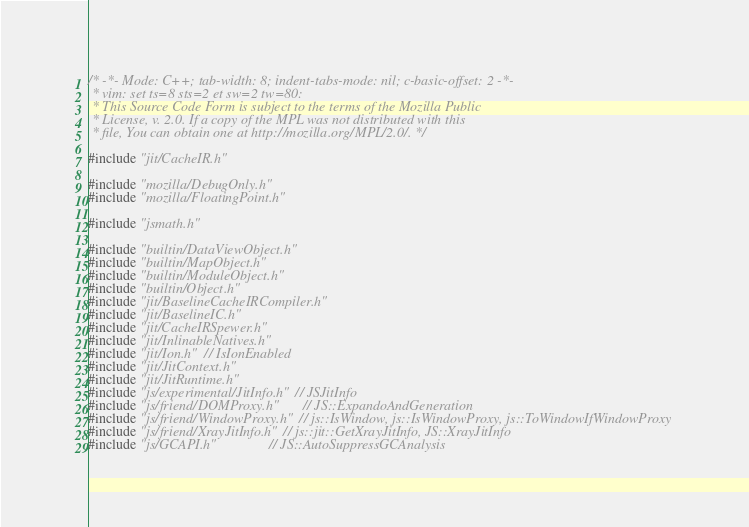Convert code to text. <code><loc_0><loc_0><loc_500><loc_500><_C++_>/* -*- Mode: C++; tab-width: 8; indent-tabs-mode: nil; c-basic-offset: 2 -*-
 * vim: set ts=8 sts=2 et sw=2 tw=80:
 * This Source Code Form is subject to the terms of the Mozilla Public
 * License, v. 2.0. If a copy of the MPL was not distributed with this
 * file, You can obtain one at http://mozilla.org/MPL/2.0/. */

#include "jit/CacheIR.h"

#include "mozilla/DebugOnly.h"
#include "mozilla/FloatingPoint.h"

#include "jsmath.h"

#include "builtin/DataViewObject.h"
#include "builtin/MapObject.h"
#include "builtin/ModuleObject.h"
#include "builtin/Object.h"
#include "jit/BaselineCacheIRCompiler.h"
#include "jit/BaselineIC.h"
#include "jit/CacheIRSpewer.h"
#include "jit/InlinableNatives.h"
#include "jit/Ion.h"  // IsIonEnabled
#include "jit/JitContext.h"
#include "jit/JitRuntime.h"
#include "js/experimental/JitInfo.h"  // JSJitInfo
#include "js/friend/DOMProxy.h"       // JS::ExpandoAndGeneration
#include "js/friend/WindowProxy.h"  // js::IsWindow, js::IsWindowProxy, js::ToWindowIfWindowProxy
#include "js/friend/XrayJitInfo.h"  // js::jit::GetXrayJitInfo, JS::XrayJitInfo
#include "js/GCAPI.h"               // JS::AutoSuppressGCAnalysis</code> 